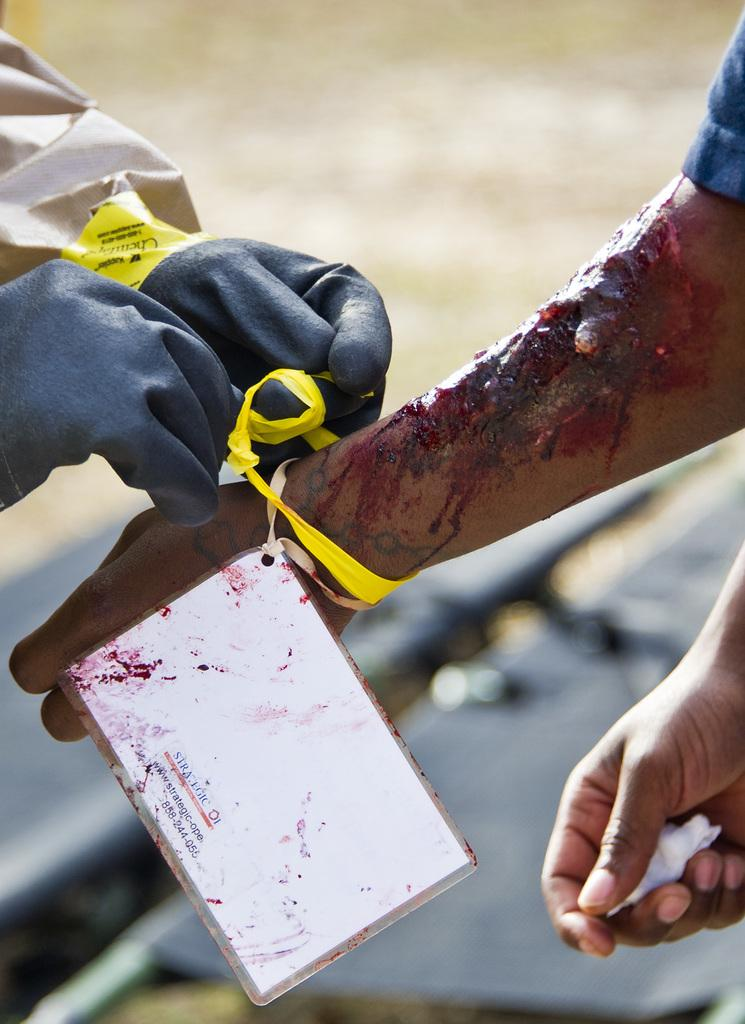What body parts are visible in the image? There are persons' hands visible in the image. Can you describe the condition of one of the hands? One of the hands is wounded. How many cattle can be seen grazing in the image? There are no cattle present in the image; it only features persons' hands. What type of creature is interacting with the wounded hand in the image? There is no creature interacting with the wounded hand in the image. 